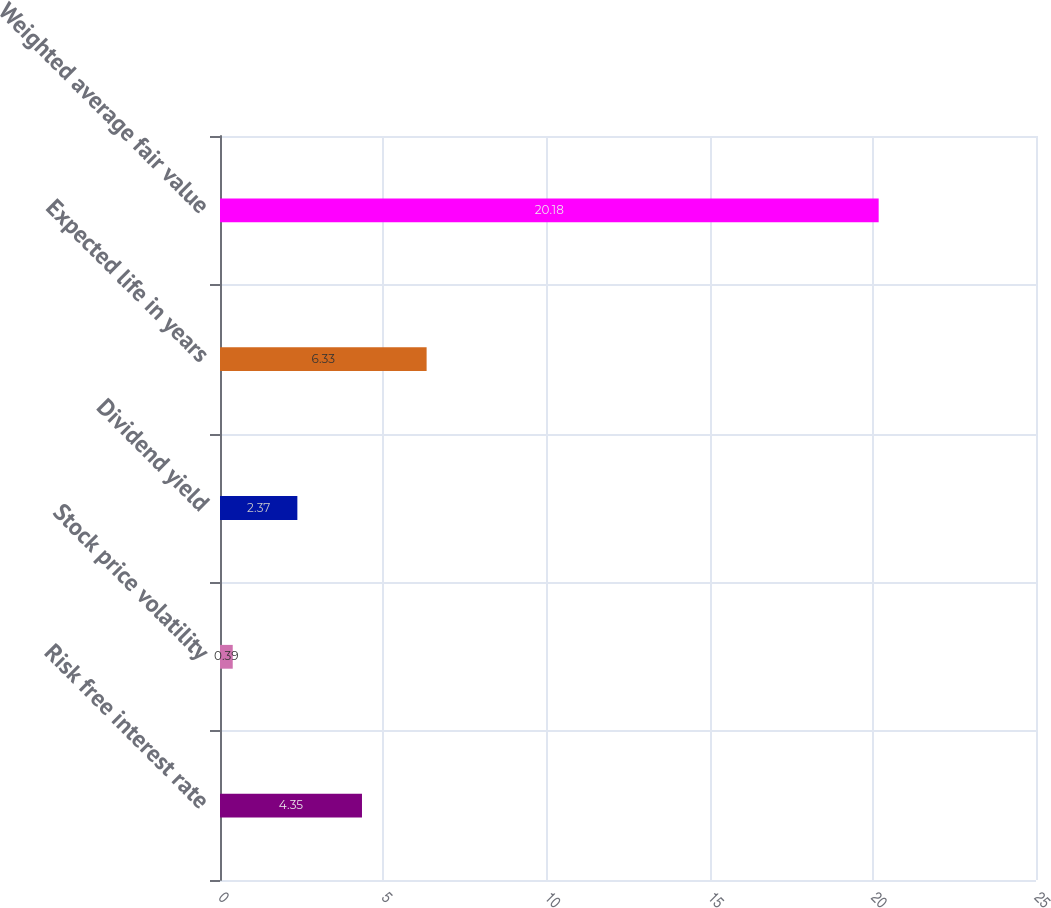Convert chart to OTSL. <chart><loc_0><loc_0><loc_500><loc_500><bar_chart><fcel>Risk free interest rate<fcel>Stock price volatility<fcel>Dividend yield<fcel>Expected life in years<fcel>Weighted average fair value<nl><fcel>4.35<fcel>0.39<fcel>2.37<fcel>6.33<fcel>20.18<nl></chart> 